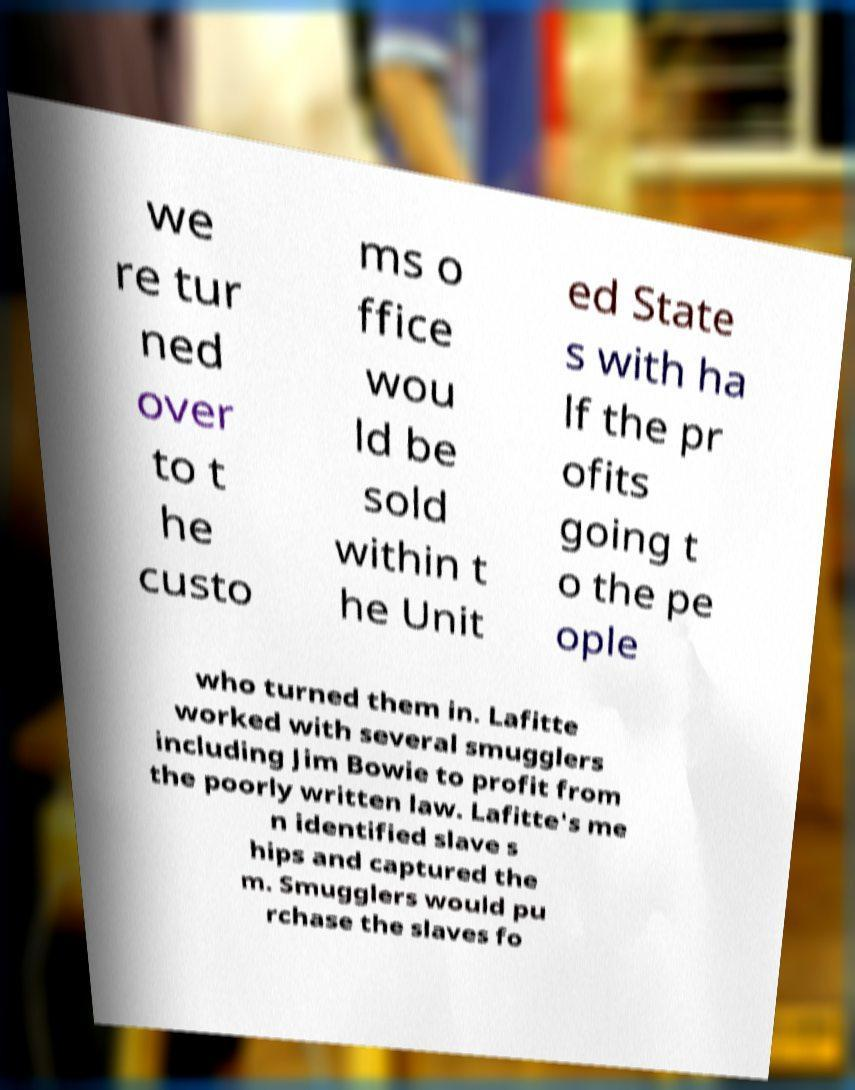Please identify and transcribe the text found in this image. we re tur ned over to t he custo ms o ffice wou ld be sold within t he Unit ed State s with ha lf the pr ofits going t o the pe ople who turned them in. Lafitte worked with several smugglers including Jim Bowie to profit from the poorly written law. Lafitte's me n identified slave s hips and captured the m. Smugglers would pu rchase the slaves fo 